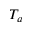<formula> <loc_0><loc_0><loc_500><loc_500>T _ { a }</formula> 